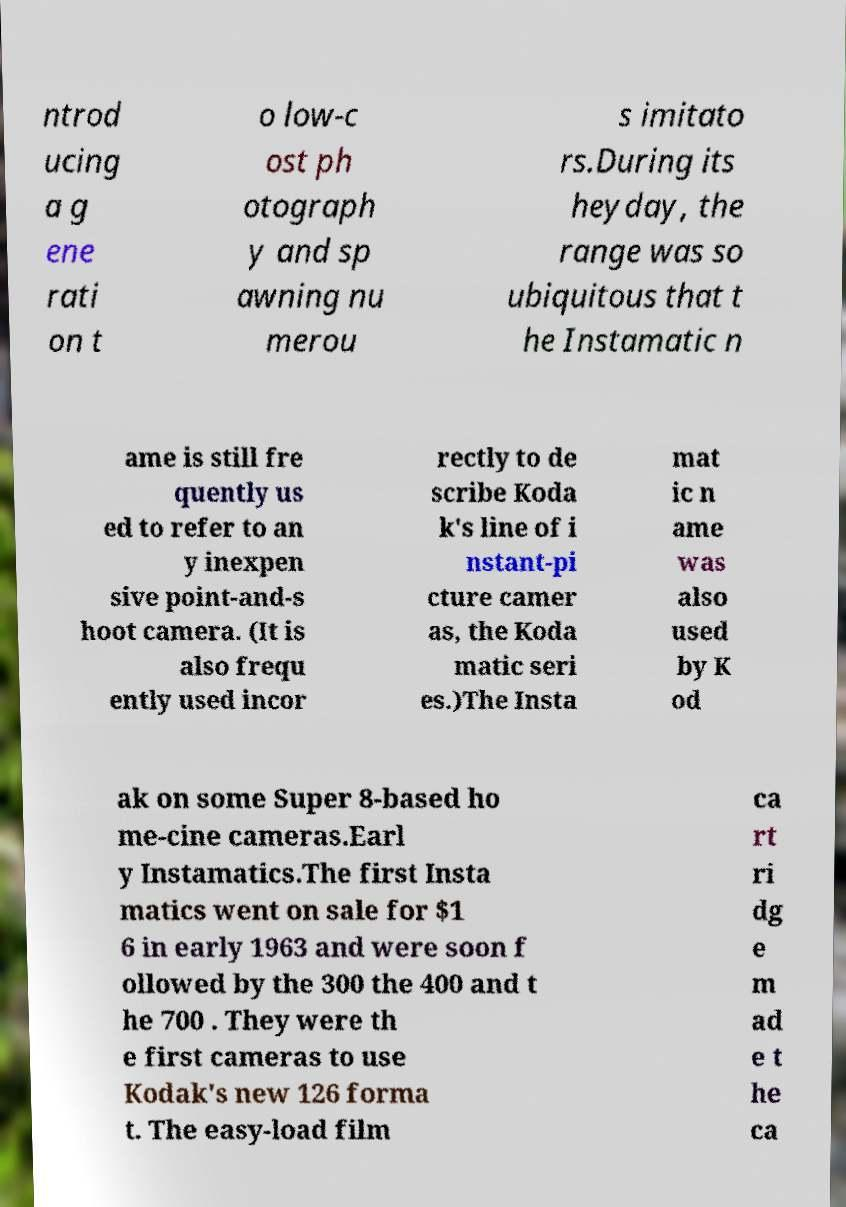There's text embedded in this image that I need extracted. Can you transcribe it verbatim? ntrod ucing a g ene rati on t o low-c ost ph otograph y and sp awning nu merou s imitato rs.During its heyday, the range was so ubiquitous that t he Instamatic n ame is still fre quently us ed to refer to an y inexpen sive point-and-s hoot camera. (It is also frequ ently used incor rectly to de scribe Koda k's line of i nstant-pi cture camer as, the Koda matic seri es.)The Insta mat ic n ame was also used by K od ak on some Super 8-based ho me-cine cameras.Earl y Instamatics.The first Insta matics went on sale for $1 6 in early 1963 and were soon f ollowed by the 300 the 400 and t he 700 . They were th e first cameras to use Kodak's new 126 forma t. The easy-load film ca rt ri dg e m ad e t he ca 